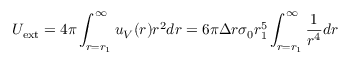<formula> <loc_0><loc_0><loc_500><loc_500>U _ { e x t } = 4 \pi \int _ { r = r _ { 1 } } ^ { \infty } u _ { V } ( r ) r ^ { 2 } d r = 6 \pi \Delta r \sigma _ { 0 } r _ { 1 } ^ { 5 } \int _ { r = r _ { 1 } } ^ { \infty } \frac { 1 } { r ^ { 4 } } d r</formula> 